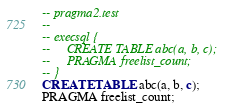<code> <loc_0><loc_0><loc_500><loc_500><_SQL_>-- pragma2.test
-- 
-- execsql {
--     CREATE TABLE abc(a, b, c);
--     PRAGMA freelist_count;
-- }
CREATE TABLE abc(a, b, c);
PRAGMA freelist_count;</code> 